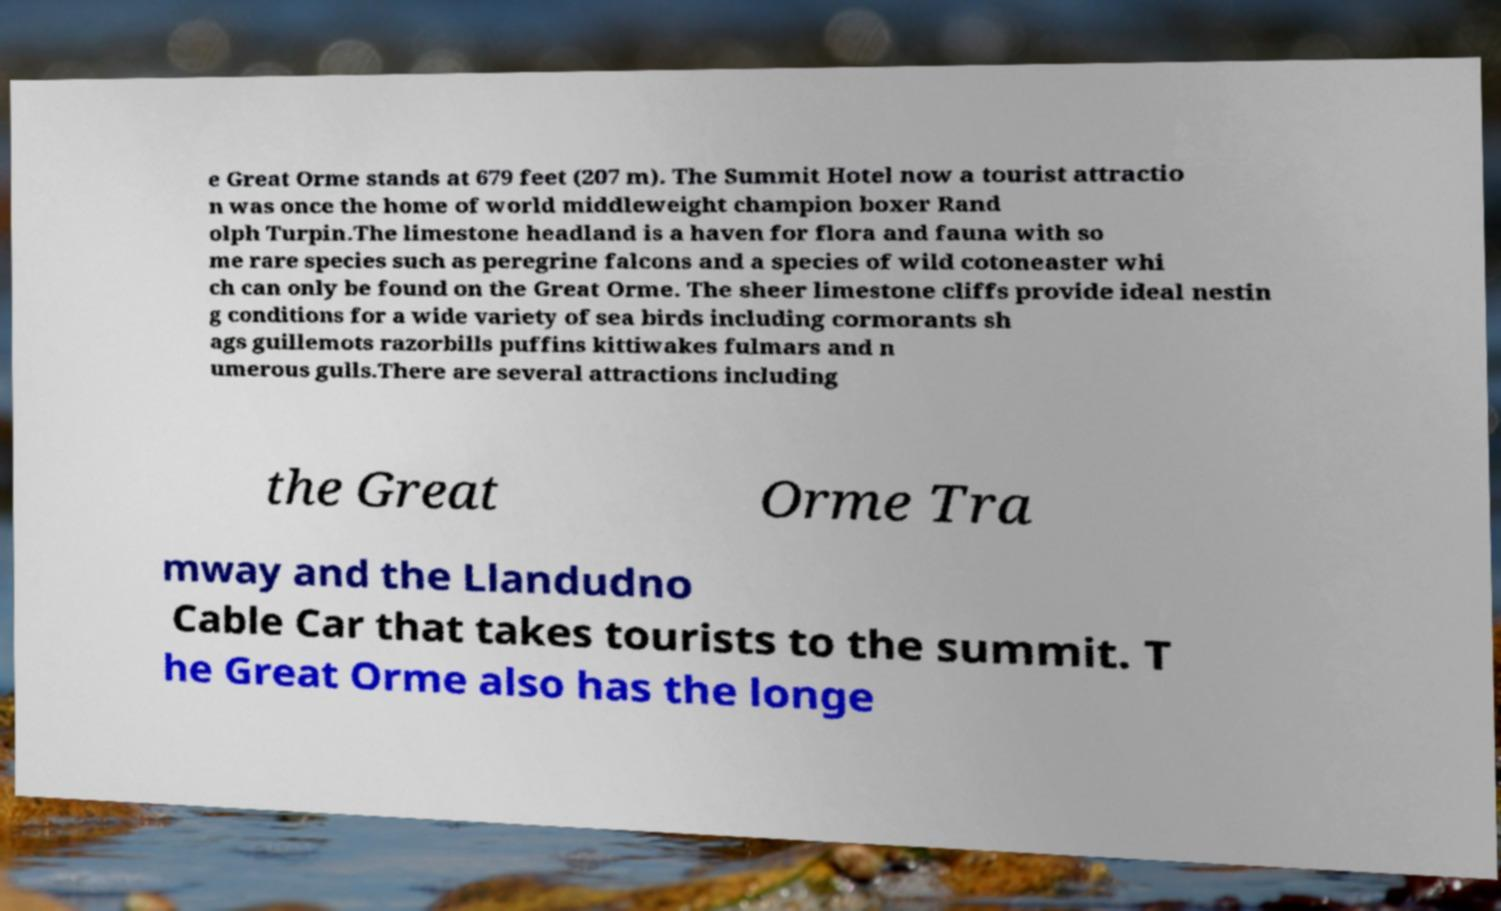For documentation purposes, I need the text within this image transcribed. Could you provide that? e Great Orme stands at 679 feet (207 m). The Summit Hotel now a tourist attractio n was once the home of world middleweight champion boxer Rand olph Turpin.The limestone headland is a haven for flora and fauna with so me rare species such as peregrine falcons and a species of wild cotoneaster whi ch can only be found on the Great Orme. The sheer limestone cliffs provide ideal nestin g conditions for a wide variety of sea birds including cormorants sh ags guillemots razorbills puffins kittiwakes fulmars and n umerous gulls.There are several attractions including the Great Orme Tra mway and the Llandudno Cable Car that takes tourists to the summit. T he Great Orme also has the longe 